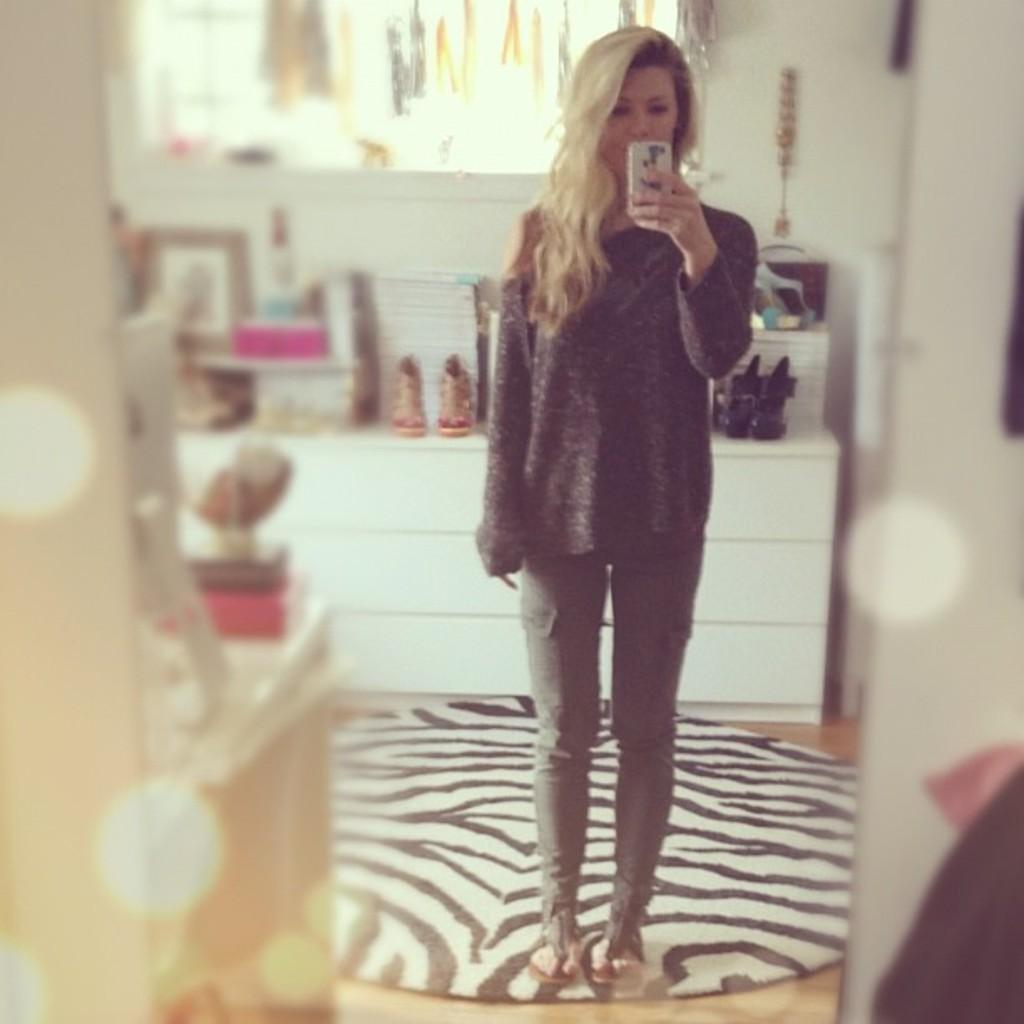Who is the main subject in the image? There is a woman in the center of the image. What is the woman doing in the image? The woman is standing on the floor. What is the woman holding in the image? The woman is holding a mobile phone. What can be seen in the background of the image? There are objects, shoes, photo frames, a wall, and a window in the background of the image. How many friends are visible in the image? There are no friends visible in the image; it only features a woman holding a mobile phone. What type of bun is being used to secure the woman's hair in the image? There is no bun visible in the image, as the woman's hair is not shown. 